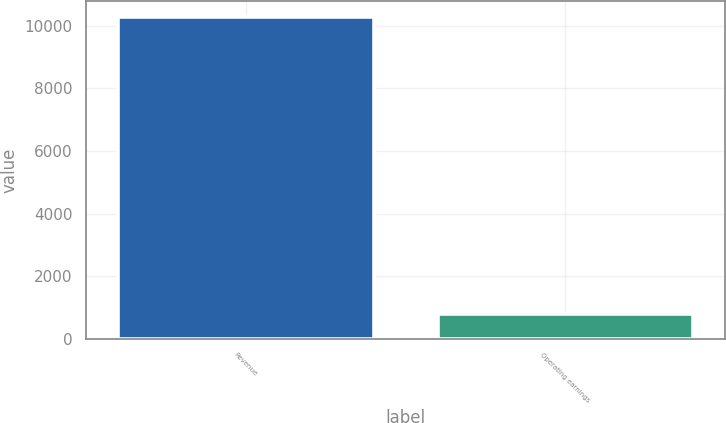Convert chart. <chart><loc_0><loc_0><loc_500><loc_500><bar_chart><fcel>Revenue<fcel>Operating earnings<nl><fcel>10268<fcel>795<nl></chart> 